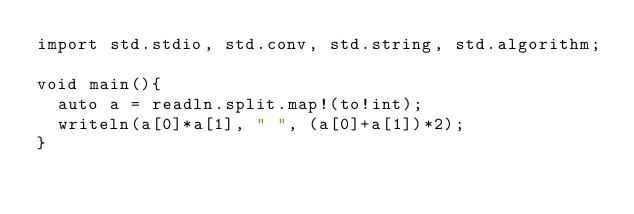Convert code to text. <code><loc_0><loc_0><loc_500><loc_500><_D_>import std.stdio, std.conv, std.string, std.algorithm;

void main(){
	auto a = readln.split.map!(to!int);
	writeln(a[0]*a[1], " ", (a[0]+a[1])*2);
}</code> 